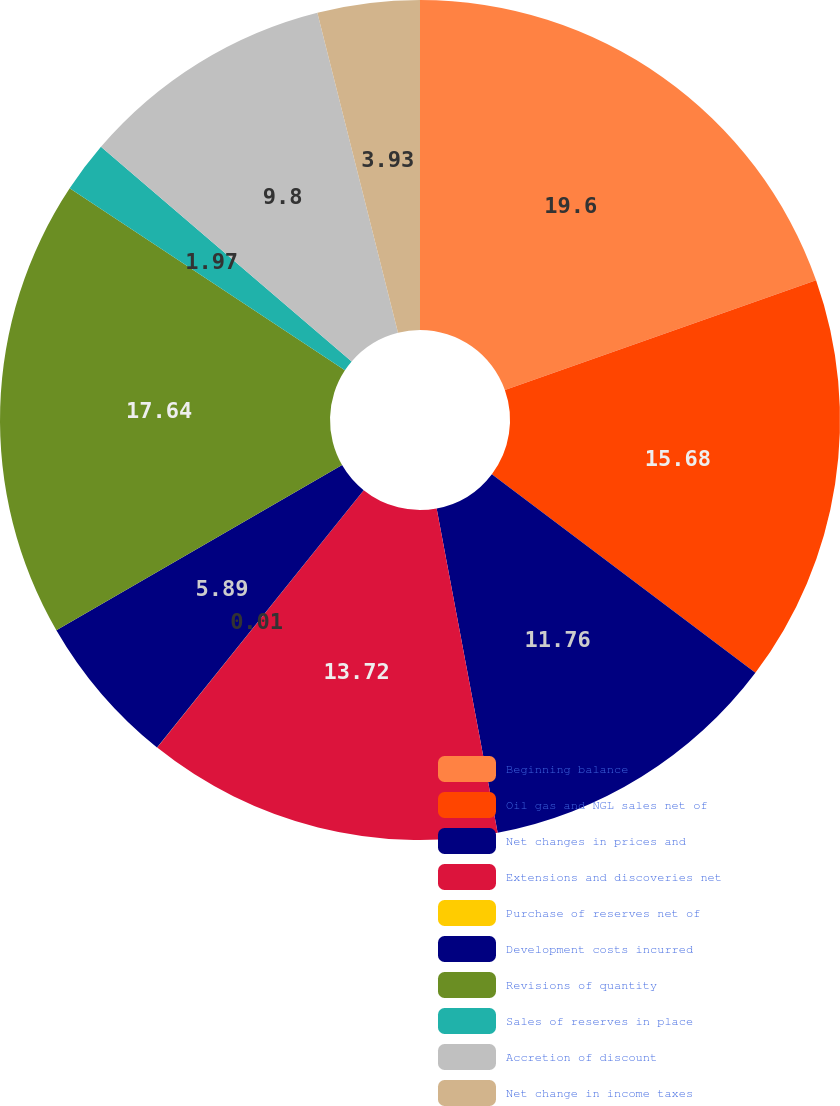Convert chart. <chart><loc_0><loc_0><loc_500><loc_500><pie_chart><fcel>Beginning balance<fcel>Oil gas and NGL sales net of<fcel>Net changes in prices and<fcel>Extensions and discoveries net<fcel>Purchase of reserves net of<fcel>Development costs incurred<fcel>Revisions of quantity<fcel>Sales of reserves in place<fcel>Accretion of discount<fcel>Net change in income taxes<nl><fcel>19.6%<fcel>15.68%<fcel>11.76%<fcel>13.72%<fcel>0.01%<fcel>5.89%<fcel>17.64%<fcel>1.97%<fcel>9.8%<fcel>3.93%<nl></chart> 